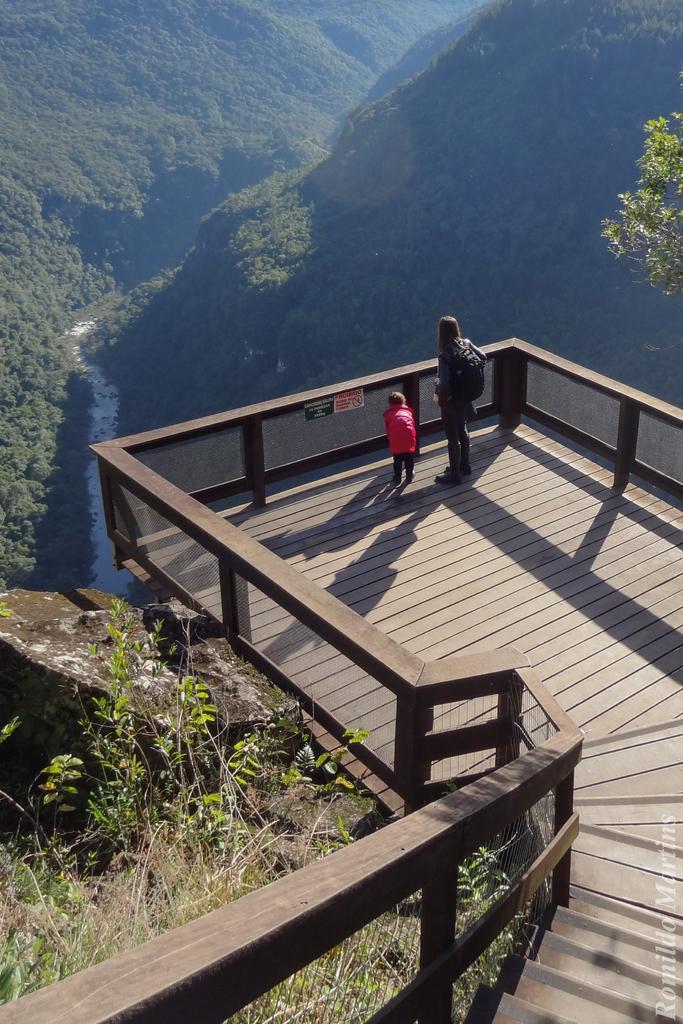Please provide a concise description of this image. In this image there are two people standing on the wooden platform. To the right side of the image there are staircase. There is railing. In the background of the image there are mountains, trees. There is river. 